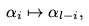Convert formula to latex. <formula><loc_0><loc_0><loc_500><loc_500>\alpha _ { i } \mapsto \alpha _ { l - i } ,</formula> 